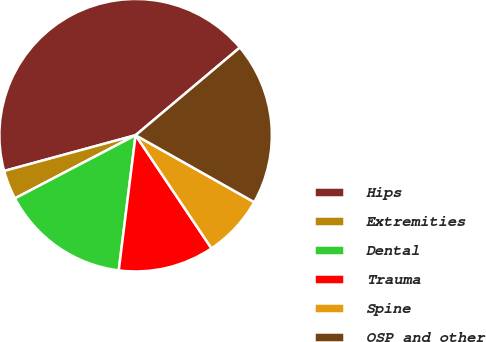Convert chart to OTSL. <chart><loc_0><loc_0><loc_500><loc_500><pie_chart><fcel>Hips<fcel>Extremities<fcel>Dental<fcel>Trauma<fcel>Spine<fcel>OSP and other<nl><fcel>43.1%<fcel>3.45%<fcel>15.35%<fcel>11.38%<fcel>7.42%<fcel>19.31%<nl></chart> 